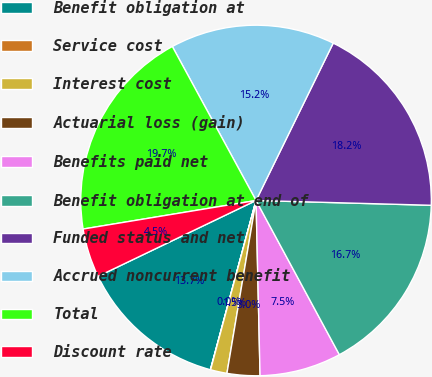Convert chart to OTSL. <chart><loc_0><loc_0><loc_500><loc_500><pie_chart><fcel>Benefit obligation at<fcel>Service cost<fcel>Interest cost<fcel>Actuarial loss (gain)<fcel>Benefits paid net<fcel>Benefit obligation at end of<fcel>Funded status and net<fcel>Accrued noncurrent benefit<fcel>Total<fcel>Discount rate<nl><fcel>13.68%<fcel>0.02%<fcel>1.52%<fcel>3.02%<fcel>7.52%<fcel>16.68%<fcel>18.18%<fcel>15.18%<fcel>19.68%<fcel>4.52%<nl></chart> 